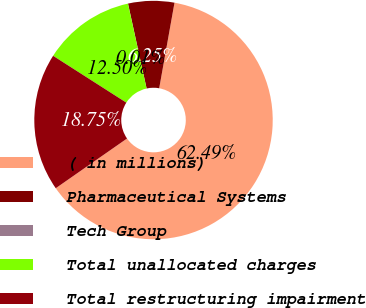<chart> <loc_0><loc_0><loc_500><loc_500><pie_chart><fcel>( in millions)<fcel>Pharmaceutical Systems<fcel>Tech Group<fcel>Total unallocated charges<fcel>Total restructuring impairment<nl><fcel>62.49%<fcel>6.25%<fcel>0.01%<fcel>12.5%<fcel>18.75%<nl></chart> 